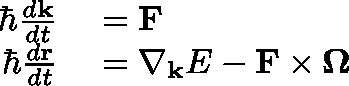<formula> <loc_0><loc_0><loc_500><loc_500>\begin{array} { r l } { \hbar { } d k } { d t } } & = F } \\ { \hbar { } d r } { d t } } & = \nabla _ { k } E - F \times \Omega } \end{array}</formula> 